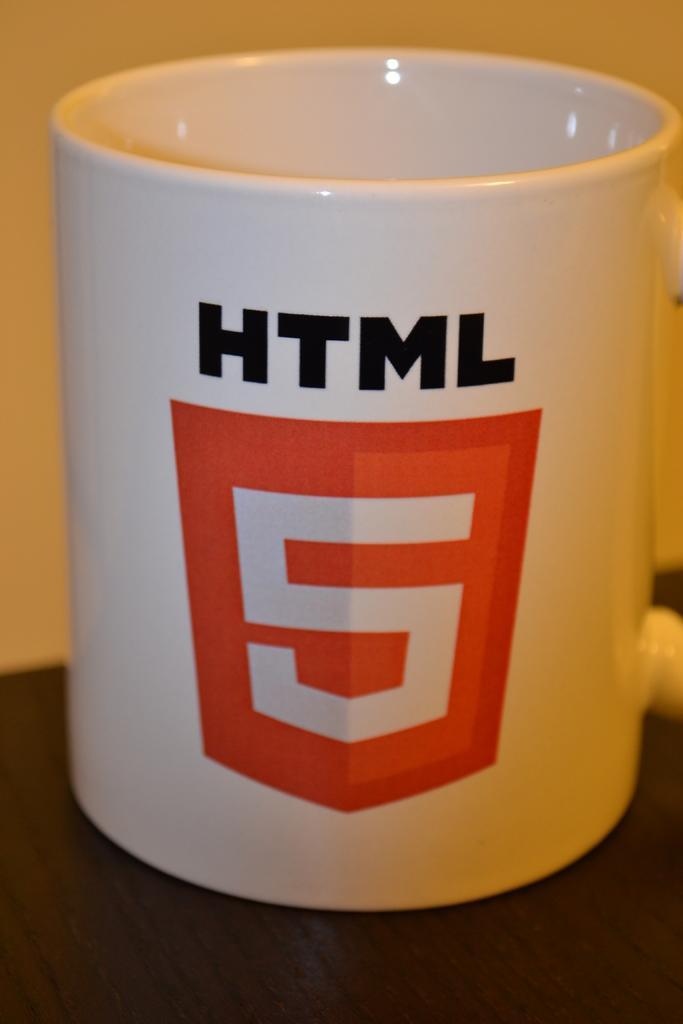Describe this image in one or two sentences. In this image I can see a white color cup and something is written on it with black and red color. Background is in cream color. 